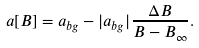<formula> <loc_0><loc_0><loc_500><loc_500>a [ B ] = a _ { b g } - | a _ { b g } | \frac { \Delta B } { B - B _ { \infty } } .</formula> 